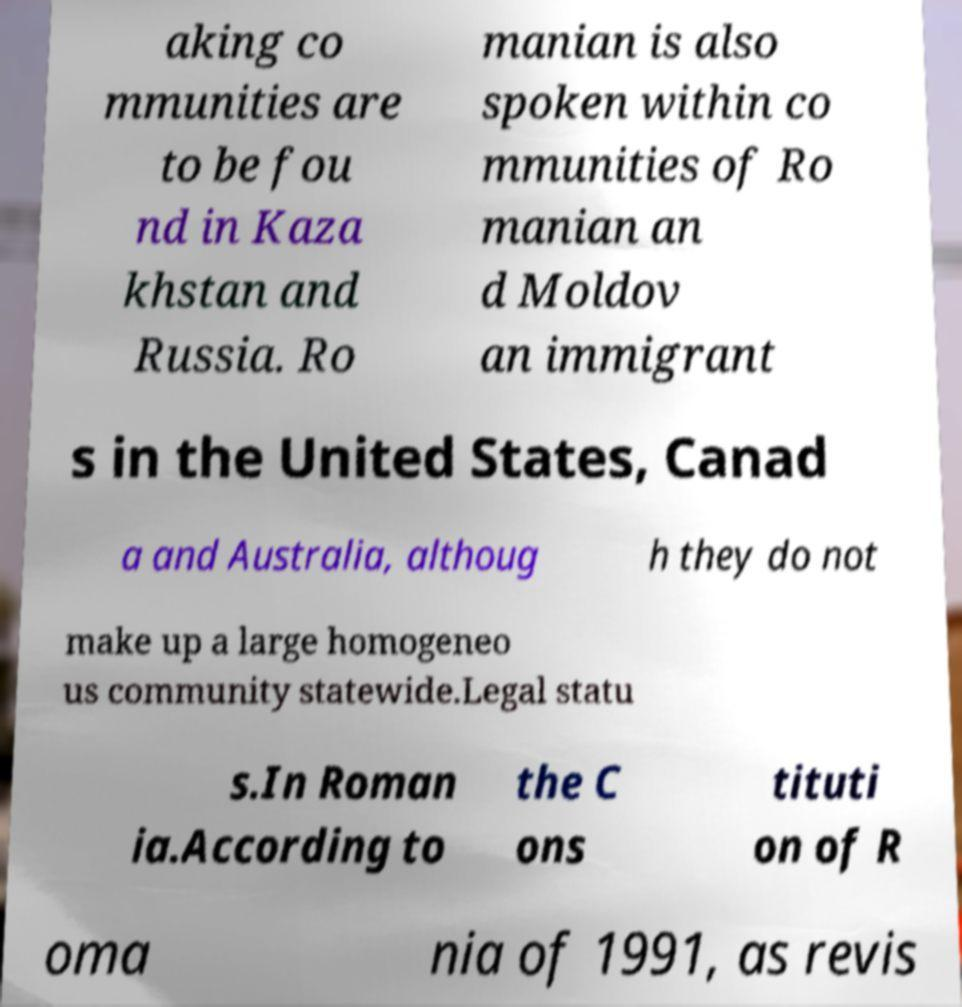What messages or text are displayed in this image? I need them in a readable, typed format. aking co mmunities are to be fou nd in Kaza khstan and Russia. Ro manian is also spoken within co mmunities of Ro manian an d Moldov an immigrant s in the United States, Canad a and Australia, althoug h they do not make up a large homogeneo us community statewide.Legal statu s.In Roman ia.According to the C ons tituti on of R oma nia of 1991, as revis 